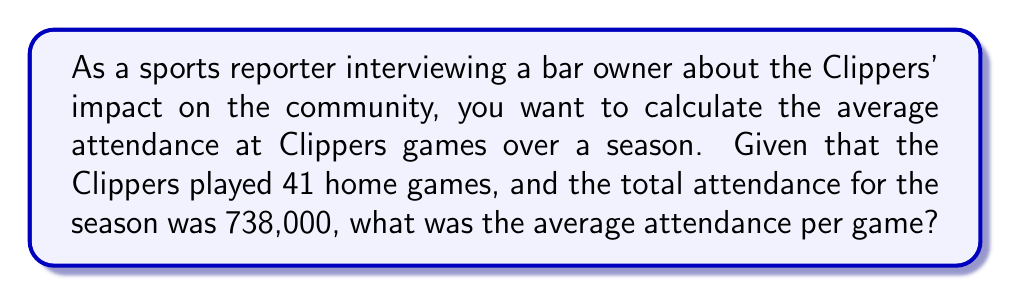Show me your answer to this math problem. To calculate the average attendance per game, we need to use the formula:

$$ \text{Average Attendance} = \frac{\text{Total Attendance}}{\text{Number of Games}} $$

Let's plug in the given values:

1. Total Attendance: 738,000
2. Number of Games: 41

$$ \text{Average Attendance} = \frac{738,000}{41} $$

Now, let's perform the division:

$$ \text{Average Attendance} = 18,000 $$

Therefore, the average attendance at Clippers games over the season was 18,000 people per game.
Answer: 18,000 people per game 